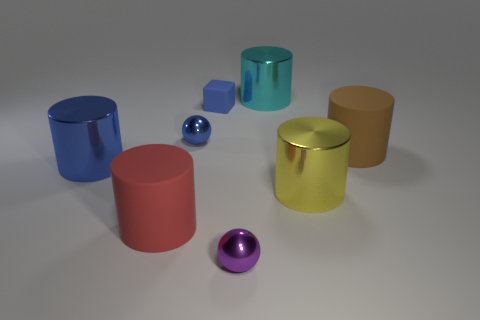Subtract all large yellow metal cylinders. How many cylinders are left? 4 Subtract 1 purple balls. How many objects are left? 7 Subtract all spheres. How many objects are left? 6 Subtract 2 spheres. How many spheres are left? 0 Subtract all yellow spheres. Subtract all yellow blocks. How many spheres are left? 2 Subtract all blue cylinders. How many yellow spheres are left? 0 Subtract all tiny rubber cubes. Subtract all big things. How many objects are left? 2 Add 3 matte cubes. How many matte cubes are left? 4 Add 5 big rubber spheres. How many big rubber spheres exist? 5 Add 2 purple shiny balls. How many objects exist? 10 